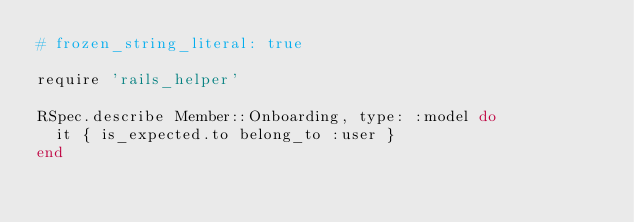Convert code to text. <code><loc_0><loc_0><loc_500><loc_500><_Ruby_># frozen_string_literal: true

require 'rails_helper'

RSpec.describe Member::Onboarding, type: :model do
  it { is_expected.to belong_to :user }
end
</code> 